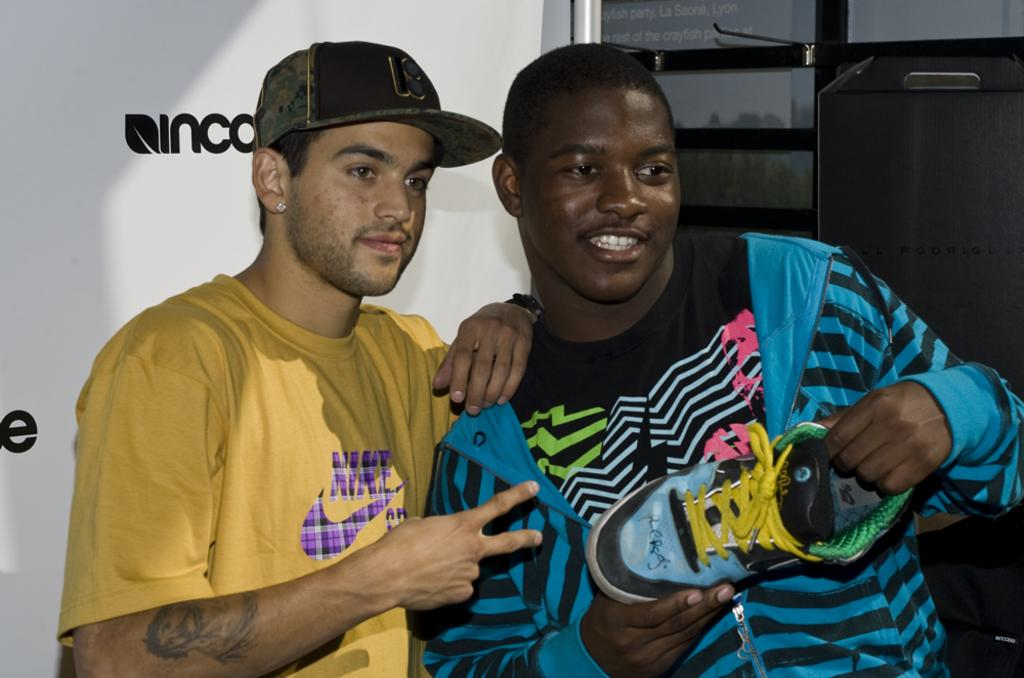Provide a one-sentence caption for the provided image. A black man holding a shoe is standing next to a white man with a yellow Nike shirt. 